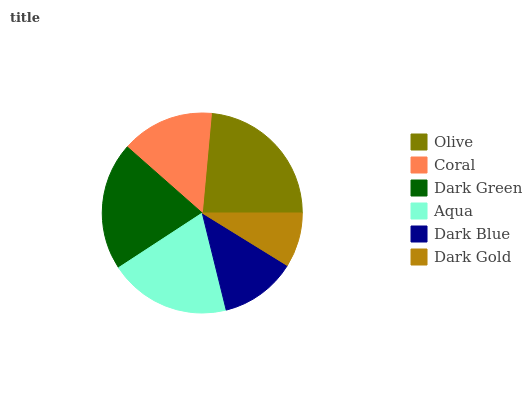Is Dark Gold the minimum?
Answer yes or no. Yes. Is Olive the maximum?
Answer yes or no. Yes. Is Coral the minimum?
Answer yes or no. No. Is Coral the maximum?
Answer yes or no. No. Is Olive greater than Coral?
Answer yes or no. Yes. Is Coral less than Olive?
Answer yes or no. Yes. Is Coral greater than Olive?
Answer yes or no. No. Is Olive less than Coral?
Answer yes or no. No. Is Aqua the high median?
Answer yes or no. Yes. Is Coral the low median?
Answer yes or no. Yes. Is Dark Green the high median?
Answer yes or no. No. Is Dark Green the low median?
Answer yes or no. No. 